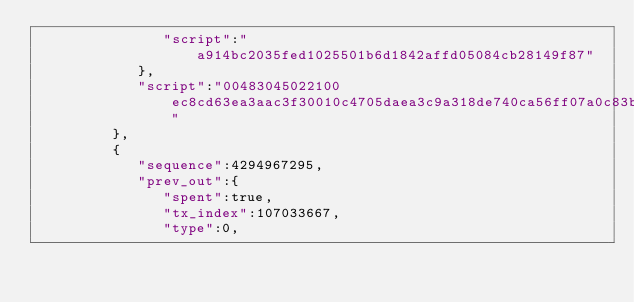<code> <loc_0><loc_0><loc_500><loc_500><_XML_>               "script":"a914bc2035fed1025501b6d1842affd05084cb28149f87"
            },
            "script":"00483045022100ec8cd63ea3aac3f30010c4705daea3c9a318de740ca56ff07a0c83b56bee38c50220768cdb78f38028df401d52afda85a320d0b385f6c9676d098161caf420ee792f01483045022100988a7f2ef6c2ae9248a1348bb2a6eb6b4bba145e0f901991bc000e9b4ea8272a02204f90bb9a9ebcd723068fe0a839c48f44c9e115b330ee80eb89ae9d5e58e202cd014c69522102eff26285d714100f0aa6a29822a2ae68afccc7b6dd2128beabd2fbcfdb3bc5ff21034c1756b3ae7ff26700d1d9885193955f0185c9dba1ac4c835c8c4b5644551986210290afebb936d3c3649fa180ef3b92d88ba01fa5ffc08c8732b2387601a659c31153ae"
         },
         {
            "sequence":4294967295,
            "prev_out":{
               "spent":true,
               "tx_index":107033667,
               "type":0,</code> 